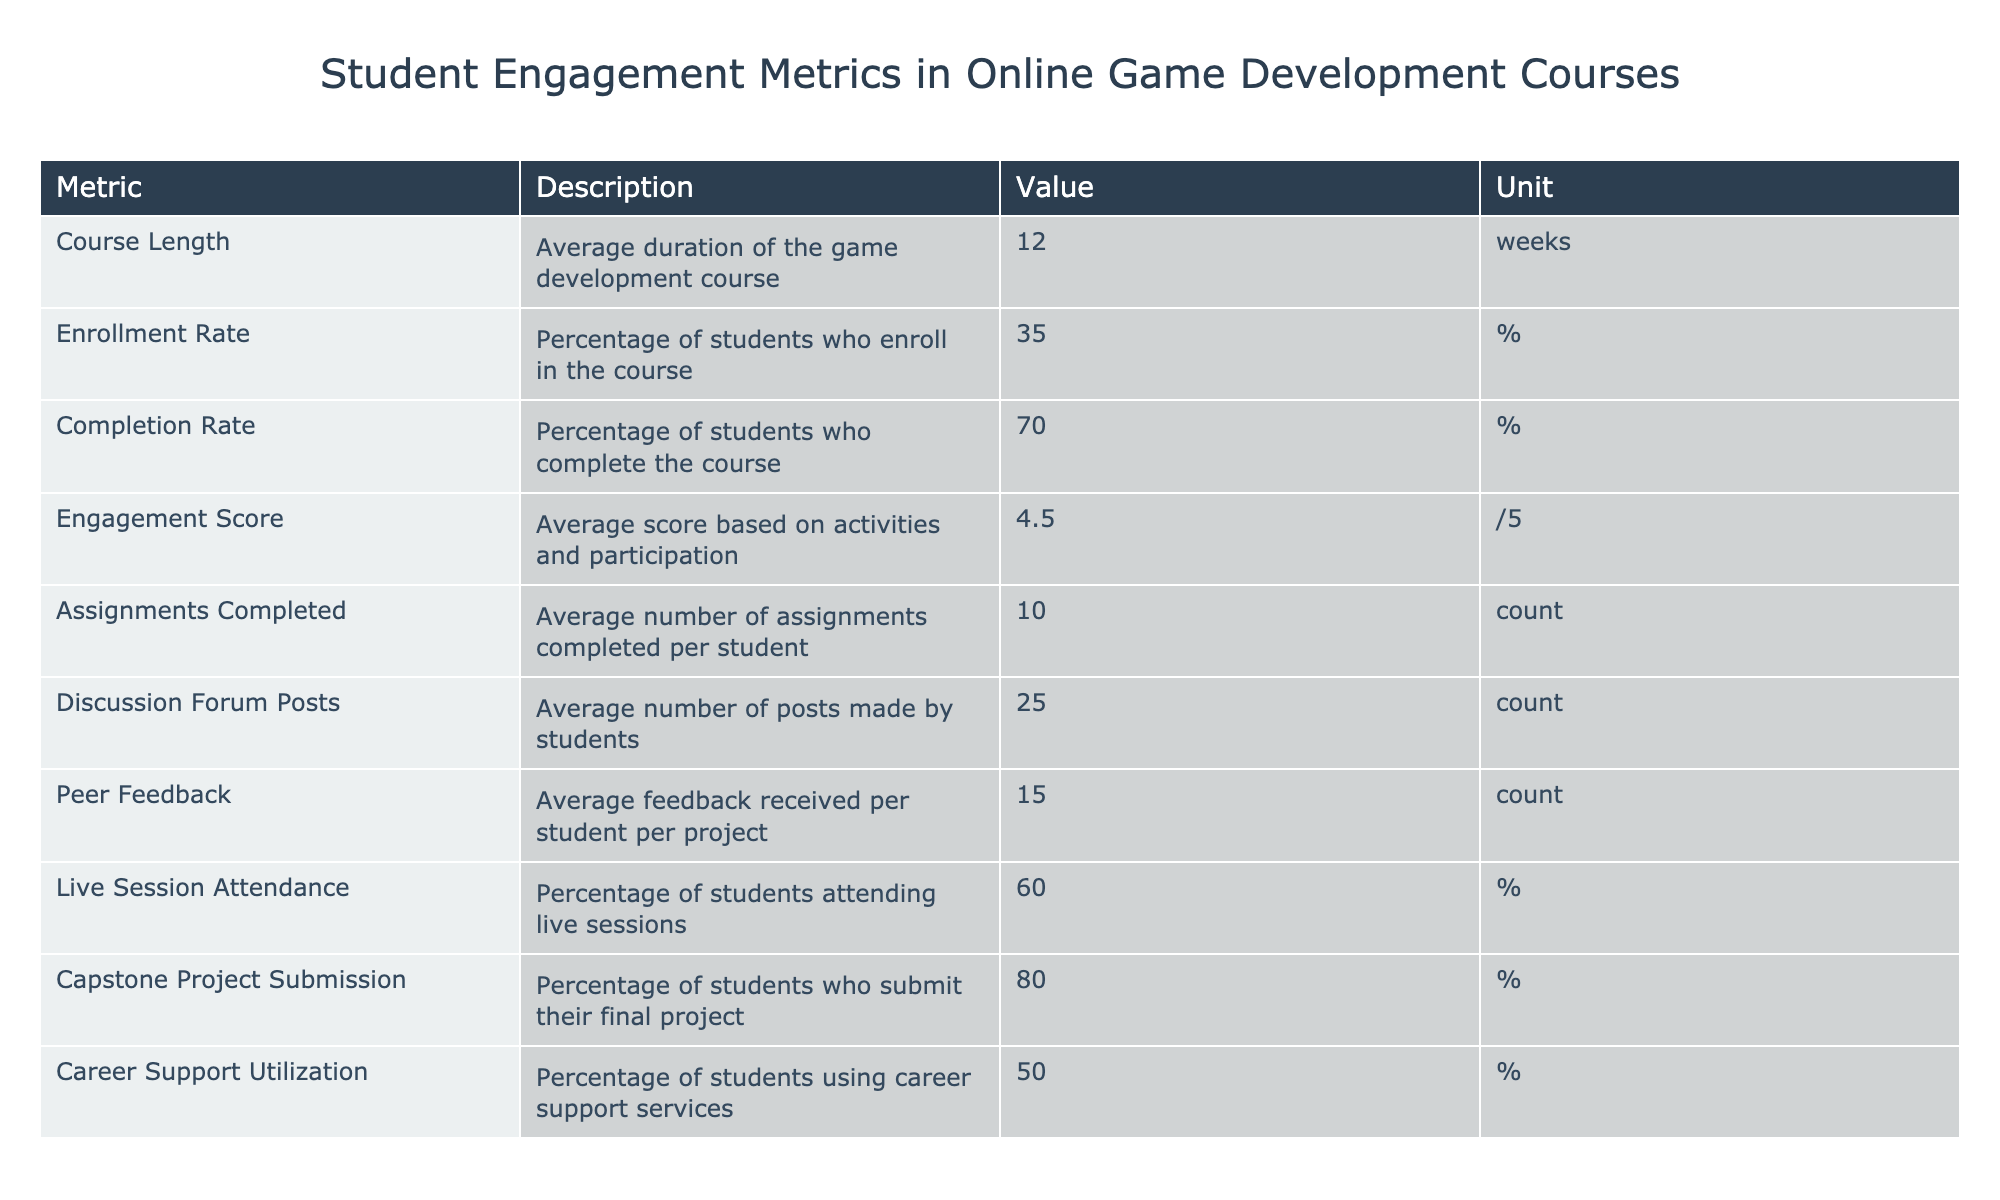What is the average duration of the game development course? The table shows the metrics, and under the row labeled "Course Length," the value is listed as 12 weeks, which indicates the average duration of the course.
Answer: 12 weeks What percentage of students complete the course? The table indicates that the "Completion Rate" is 70%, which specifically answers the question about how many students complete the course.
Answer: 70% Is the engagement score higher than 4? Looking at the "Engagement Score" in the table, the value is 4.5, which is indeed higher than 4, confirming that the statement is true.
Answer: Yes How many average assignments do students complete? The table's "Assignments Completed" row shows an average of 10 assignments completed per student, directly answering the question.
Answer: 10 If 100 students enroll, how many are likely to complete the course? First, we take the Enrollment Rate of 35% from the total of 100 students, which means 35 students enroll. Next, we apply the Completion Rate of 70% to these 35 students, resulting in 35 * 0.70 = 24.5. Thus, we can round down to 24 students likely to complete the course.
Answer: 24 What is the percentage of students who attend live sessions? By examining the "Live Session Attendance" row in the table, we see that the percentage of students attending live sessions is listed as 60%.
Answer: 60% Is the average number of discussion forum posts made by students greater than 20? The table shows that the "Discussion Forum Posts" average is 25. Since 25 is greater than 20, the answer to the question is yes.
Answer: Yes What is the difference in percentage between course completion and capstone project submission? The Completion Rate is 70% and the Capstone Project Submission rate is 80%. Calculating the difference gives us 80 - 70 = 10%. Therefore, the difference in percentage is 10%.
Answer: 10% How many pieces of peer feedback does an average student receive per project? According to the "Peer Feedback" metric in the table, the average feedback received per student per project is listed as 15 counts.
Answer: 15 